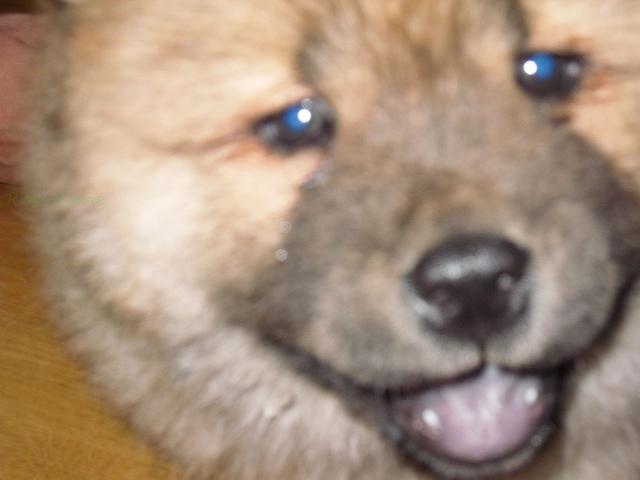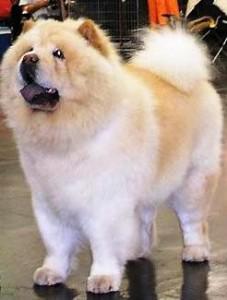The first image is the image on the left, the second image is the image on the right. Given the left and right images, does the statement "A chow with orange-tinged fur is posed on a greenish surface in at least one image." hold true? Answer yes or no. No. The first image is the image on the left, the second image is the image on the right. For the images shown, is this caption "The dogs are standing outside, but not on the grass." true? Answer yes or no. No. 